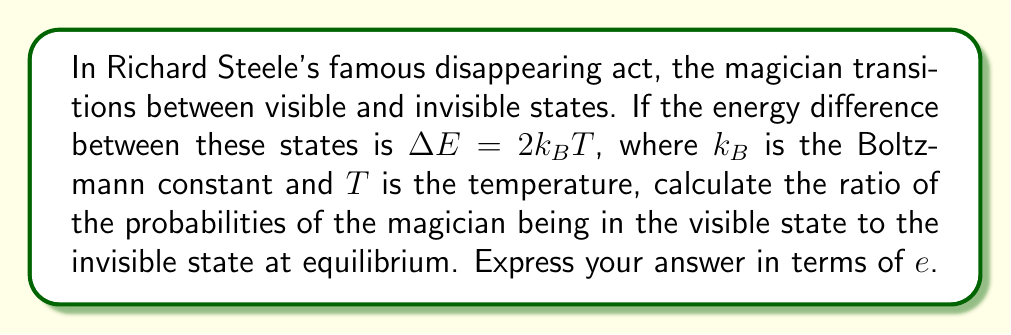Teach me how to tackle this problem. Let's approach this step-by-step using concepts from statistical mechanics:

1) The partition function for a two-state system is given by:

   $$Z = e^{-\beta E_1} + e^{-\beta E_2}$$

   where $\beta = \frac{1}{k_BT}$

2) Let's assign $E_1 = 0$ for the visible state and $E_2 = \Delta E$ for the invisible state.

3) The partition function becomes:

   $$Z = 1 + e^{-\beta \Delta E}$$

4) The probability of being in state $i$ is given by:

   $$P_i = \frac{e^{-\beta E_i}}{Z}$$

5) For the visible state (state 1):

   $$P_1 = \frac{1}{1 + e^{-\beta \Delta E}}$$

6) For the invisible state (state 2):

   $$P_2 = \frac{e^{-\beta \Delta E}}{1 + e^{-\beta \Delta E}}$$

7) The ratio of probabilities is:

   $$\frac{P_1}{P_2} = \frac{1}{e^{-\beta \Delta E}}$$

8) We're given that $\Delta E = 2k_BT$. Substituting this:

   $$\frac{P_1}{P_2} = \frac{1}{e^{-\beta (2k_BT)}} = \frac{1}{e^{-2}} = e^2$$

Thus, the ratio of probabilities of the magician being in the visible state to the invisible state is $e^2$.
Answer: $e^2$ 